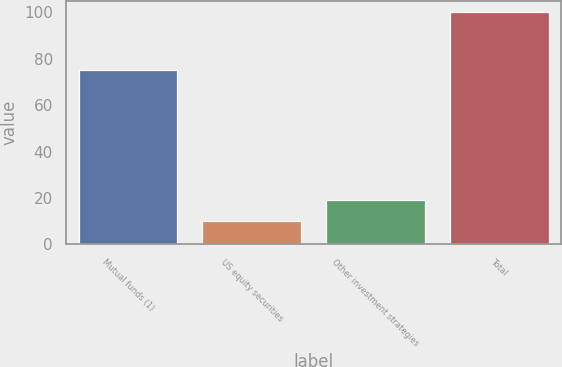Convert chart to OTSL. <chart><loc_0><loc_0><loc_500><loc_500><bar_chart><fcel>Mutual funds (1)<fcel>US equity securities<fcel>Other investment strategies<fcel>Total<nl><fcel>75<fcel>10<fcel>19<fcel>100<nl></chart> 